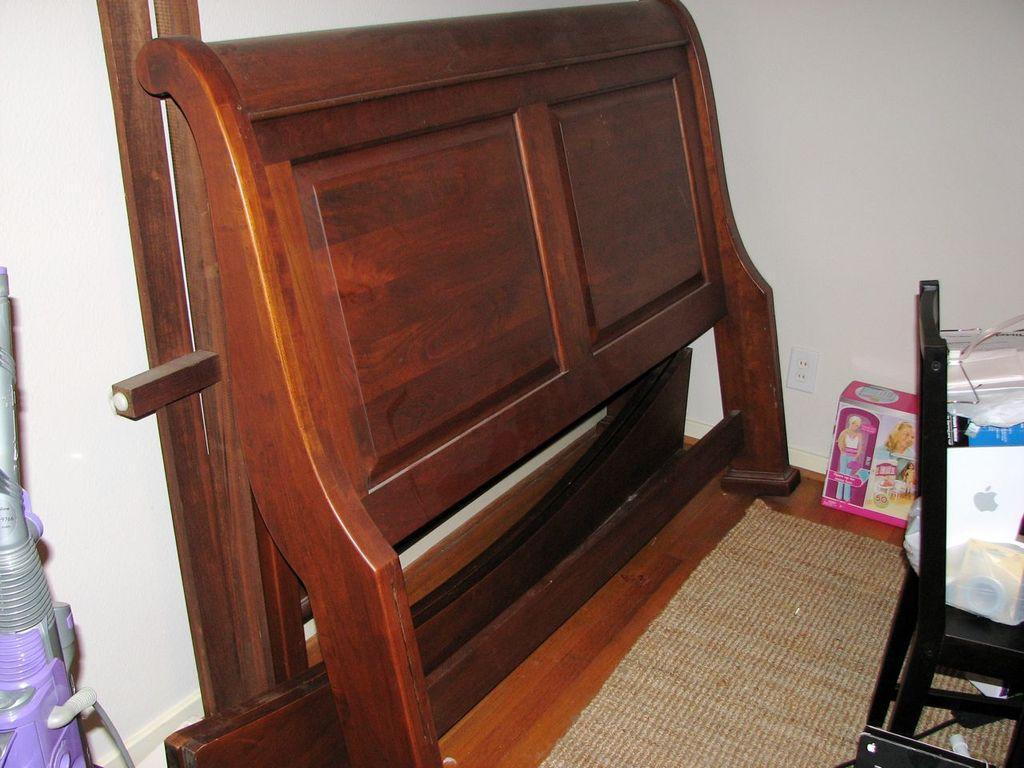In one or two sentences, can you explain what this image depicts? In this image we can see a vacuum cleaner, a wooden item, a barbie doll box, a chair, on top of the chair we can see fewer items. On the floor we can see the mat. 